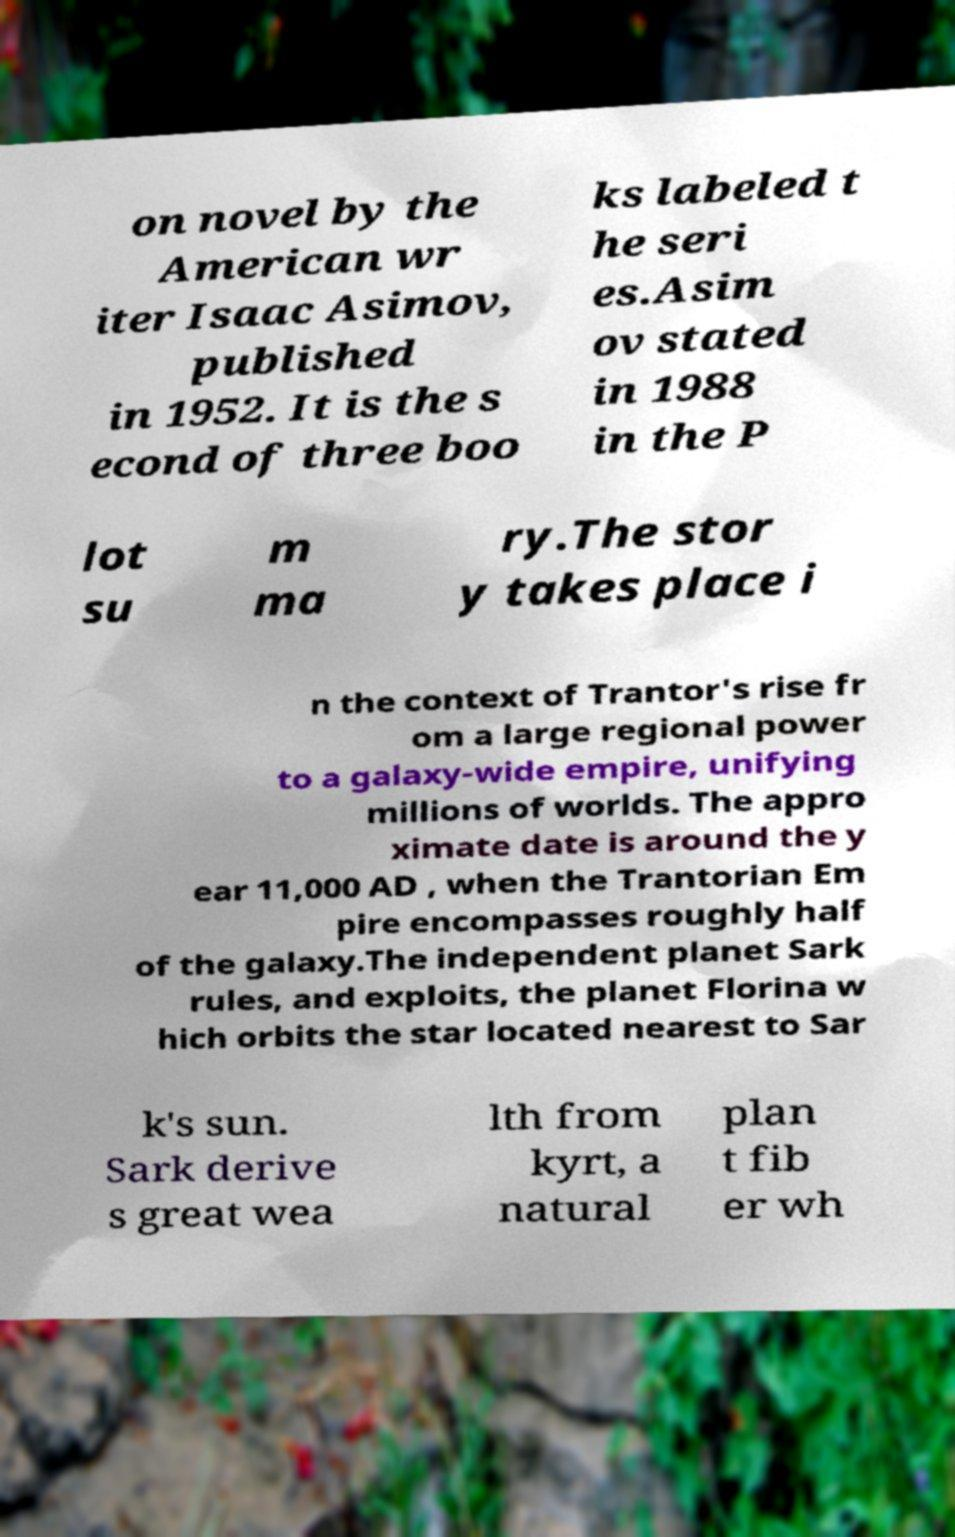Could you extract and type out the text from this image? on novel by the American wr iter Isaac Asimov, published in 1952. It is the s econd of three boo ks labeled t he seri es.Asim ov stated in 1988 in the P lot su m ma ry.The stor y takes place i n the context of Trantor's rise fr om a large regional power to a galaxy-wide empire, unifying millions of worlds. The appro ximate date is around the y ear 11,000 AD , when the Trantorian Em pire encompasses roughly half of the galaxy.The independent planet Sark rules, and exploits, the planet Florina w hich orbits the star located nearest to Sar k's sun. Sark derive s great wea lth from kyrt, a natural plan t fib er wh 